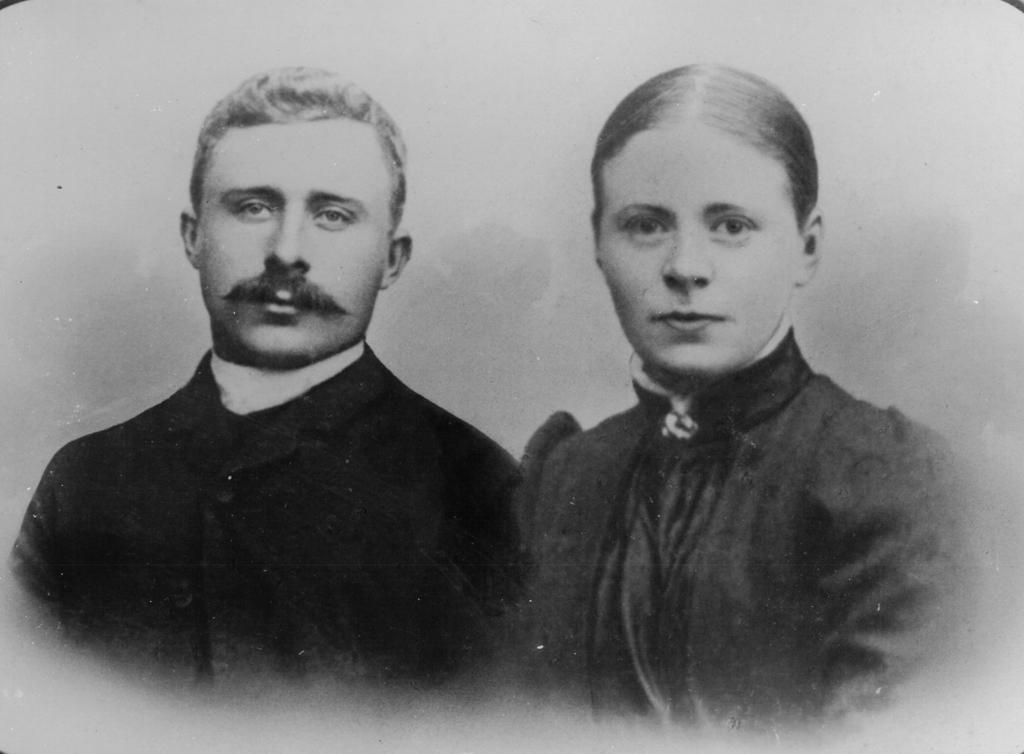What is depicted in the image? There is a drawing of a man and woman in the image. How are the man and woman positioned in the drawing? The man and woman are standing together in the drawing. What type of bat is flying in the background of the drawing? There is no bat present in the drawing; it features a man and woman standing together. 